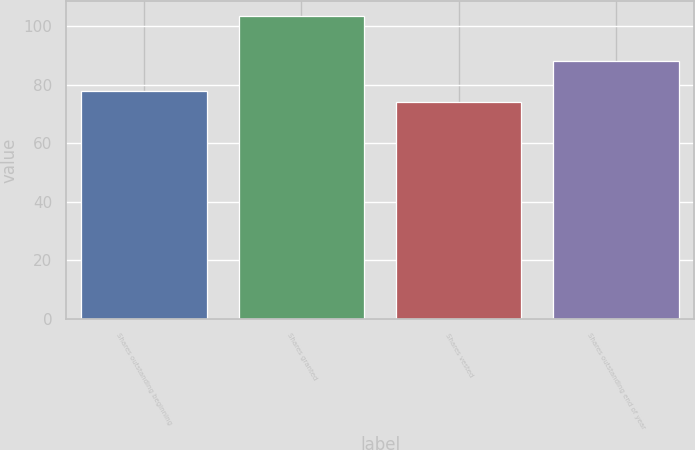Convert chart. <chart><loc_0><loc_0><loc_500><loc_500><bar_chart><fcel>Shares outstanding beginning<fcel>Shares granted<fcel>Shares vested<fcel>Shares outstanding end of year<nl><fcel>77.9<fcel>103.51<fcel>74<fcel>88.13<nl></chart> 